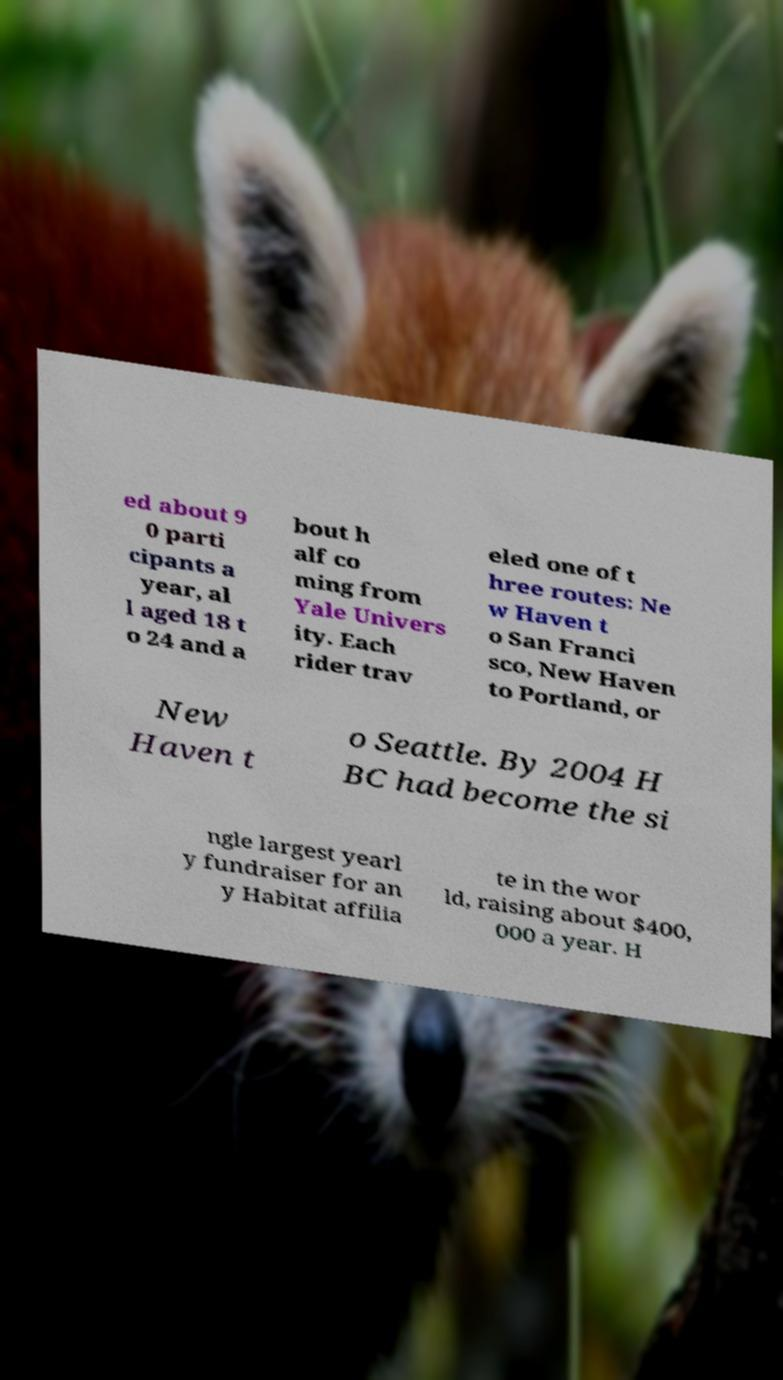Could you assist in decoding the text presented in this image and type it out clearly? ed about 9 0 parti cipants a year, al l aged 18 t o 24 and a bout h alf co ming from Yale Univers ity. Each rider trav eled one of t hree routes: Ne w Haven t o San Franci sco, New Haven to Portland, or New Haven t o Seattle. By 2004 H BC had become the si ngle largest yearl y fundraiser for an y Habitat affilia te in the wor ld, raising about $400, 000 a year. H 